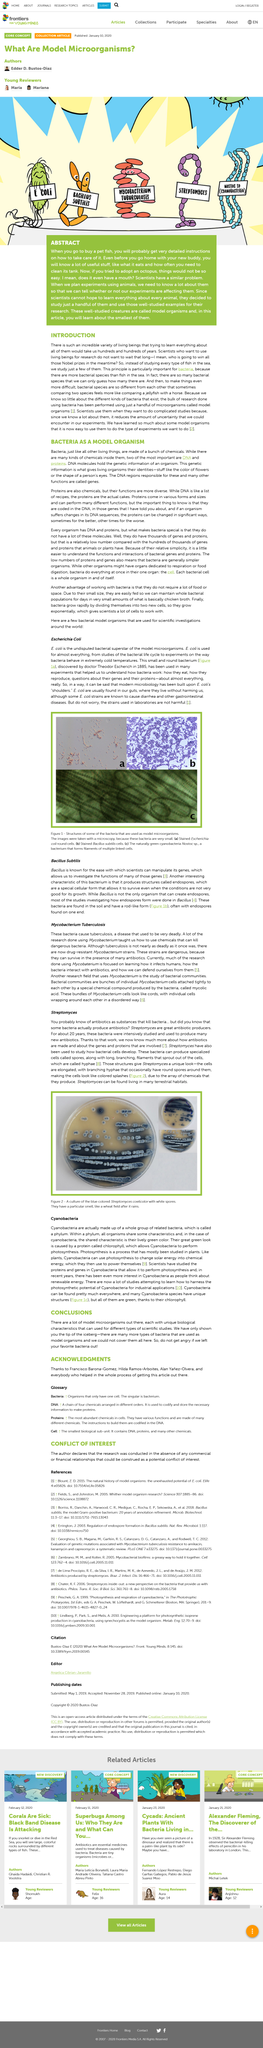Highlight a few significant elements in this photo. Streptomyces are a type of bacteria that are known for producing a wide range of antibiotics, making them excellent candidates for use in the production of antibiotics. Figure 1 depicts the bacteria Escherichia coli. Image A in the figure demonstrates the bacteria Escherichia coli. Theodore Escherich is credited with the discovery of Escherichia Coli. Scientists only study a select few living organisms instead of studying all types of living organisms, as they would study every type of fish in the sea. Streptomyces smells like a wheat field after it has rained, giving off a sweet and earthy aroma. 